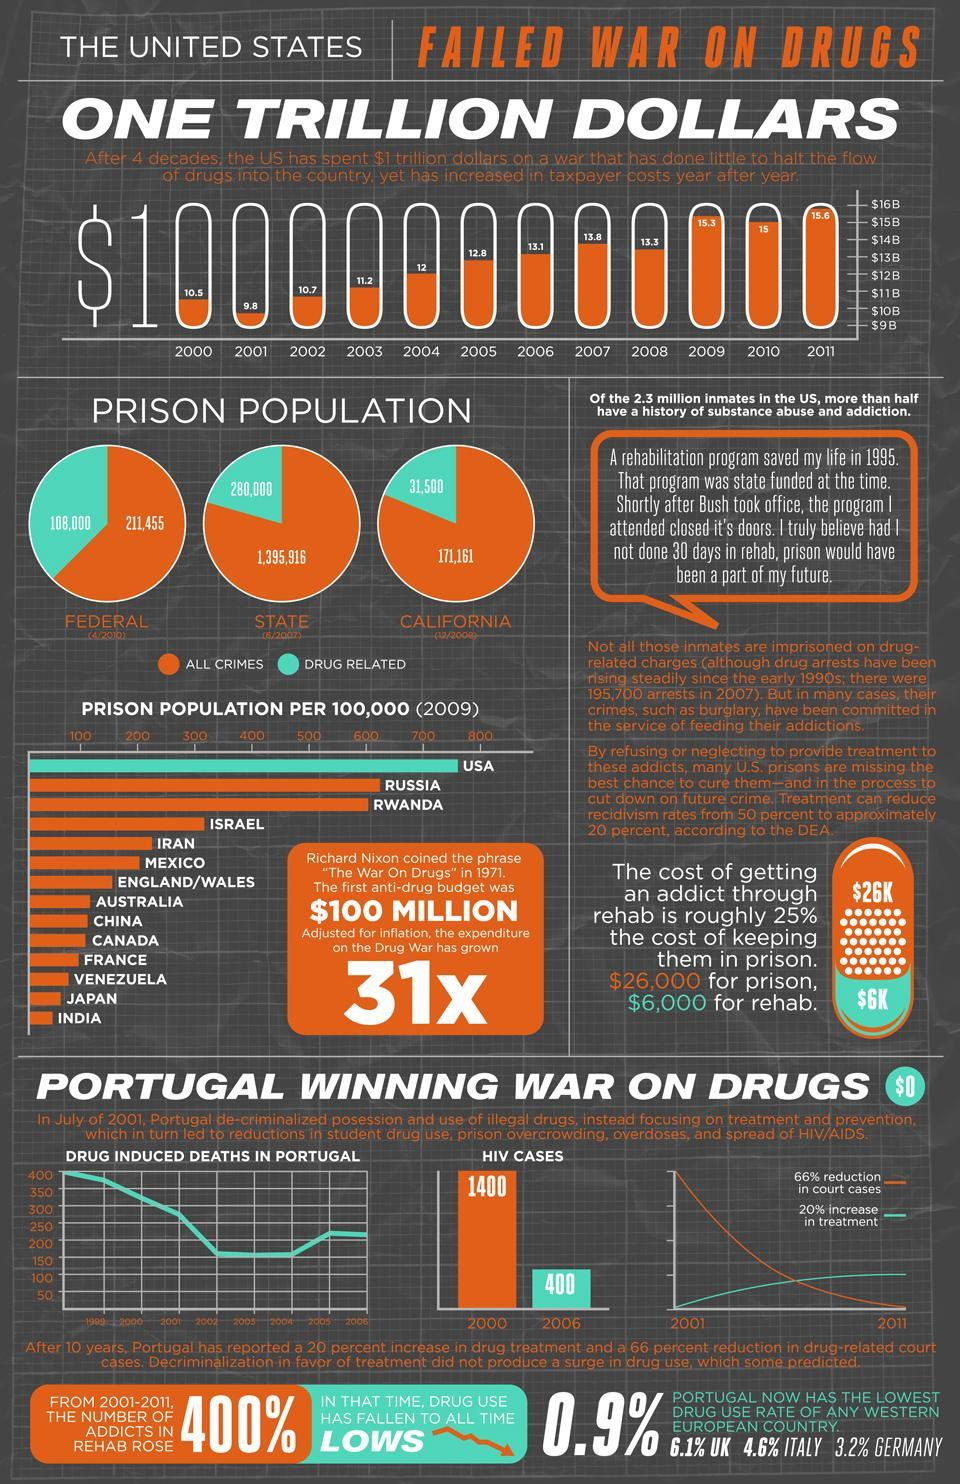what has been the decrease in HIV cases from 2000 to 2006
Answer the question with a short phrase. 1000 what has been the prison population drug related crimes in California 31,500 what is the prison population in the state for all crimes 1,395,916 which year has the spend been second lowest 2000 by how much has the expense on the war on drugs grown 31x 